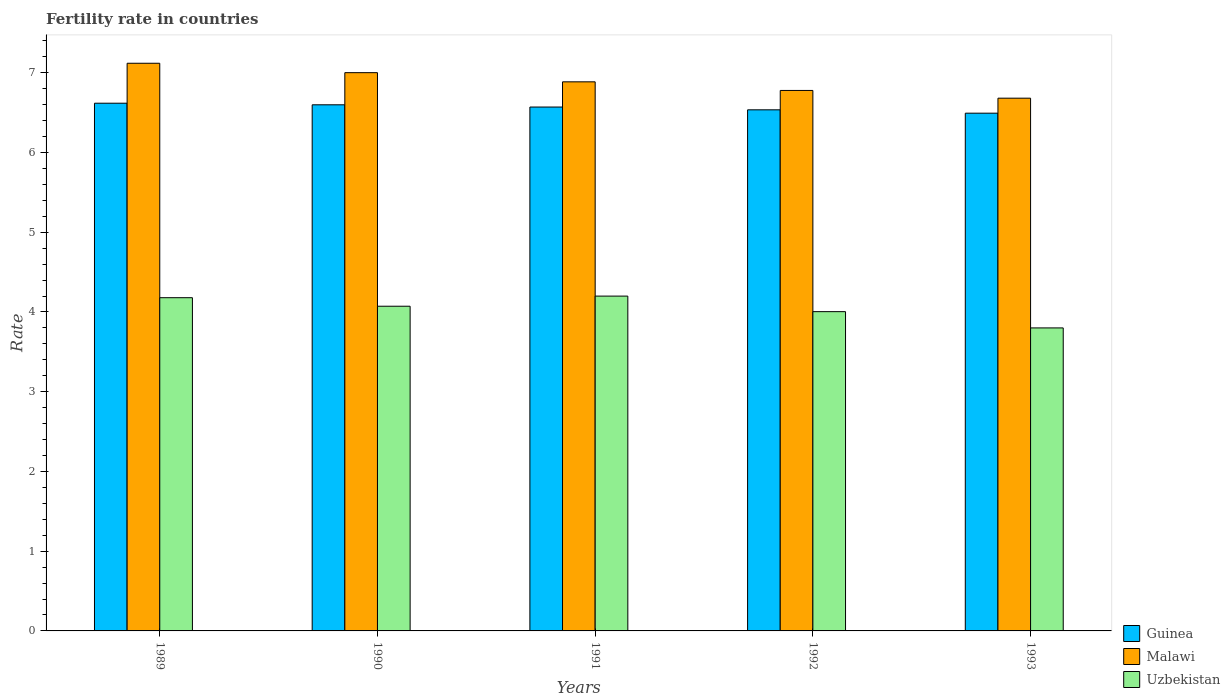How many different coloured bars are there?
Your answer should be very brief. 3. Are the number of bars per tick equal to the number of legend labels?
Offer a terse response. Yes. How many bars are there on the 4th tick from the left?
Offer a terse response. 3. How many bars are there on the 2nd tick from the right?
Provide a succinct answer. 3. In how many cases, is the number of bars for a given year not equal to the number of legend labels?
Give a very brief answer. 0. What is the fertility rate in Uzbekistan in 1990?
Give a very brief answer. 4.07. Across all years, what is the maximum fertility rate in Uzbekistan?
Make the answer very short. 4.2. Across all years, what is the minimum fertility rate in Uzbekistan?
Offer a terse response. 3.8. In which year was the fertility rate in Malawi minimum?
Offer a very short reply. 1993. What is the total fertility rate in Guinea in the graph?
Offer a terse response. 32.81. What is the difference between the fertility rate in Guinea in 1989 and that in 1993?
Make the answer very short. 0.12. What is the difference between the fertility rate in Guinea in 1991 and the fertility rate in Uzbekistan in 1990?
Make the answer very short. 2.5. What is the average fertility rate in Malawi per year?
Give a very brief answer. 6.89. In the year 1989, what is the difference between the fertility rate in Malawi and fertility rate in Guinea?
Give a very brief answer. 0.5. What is the ratio of the fertility rate in Guinea in 1990 to that in 1993?
Offer a terse response. 1.02. Is the difference between the fertility rate in Malawi in 1989 and 1992 greater than the difference between the fertility rate in Guinea in 1989 and 1992?
Provide a short and direct response. Yes. What is the difference between the highest and the second highest fertility rate in Uzbekistan?
Keep it short and to the point. 0.02. What is the difference between the highest and the lowest fertility rate in Uzbekistan?
Make the answer very short. 0.4. What does the 1st bar from the left in 1993 represents?
Provide a succinct answer. Guinea. What does the 2nd bar from the right in 1991 represents?
Offer a very short reply. Malawi. Is it the case that in every year, the sum of the fertility rate in Uzbekistan and fertility rate in Malawi is greater than the fertility rate in Guinea?
Your answer should be very brief. Yes. How many bars are there?
Provide a succinct answer. 15. Are all the bars in the graph horizontal?
Ensure brevity in your answer.  No. Does the graph contain any zero values?
Your answer should be very brief. No. Where does the legend appear in the graph?
Ensure brevity in your answer.  Bottom right. How many legend labels are there?
Give a very brief answer. 3. How are the legend labels stacked?
Offer a very short reply. Vertical. What is the title of the graph?
Offer a very short reply. Fertility rate in countries. What is the label or title of the Y-axis?
Your answer should be compact. Rate. What is the Rate of Guinea in 1989?
Your response must be concise. 6.62. What is the Rate of Malawi in 1989?
Make the answer very short. 7.12. What is the Rate in Uzbekistan in 1989?
Your answer should be very brief. 4.18. What is the Rate of Guinea in 1990?
Ensure brevity in your answer.  6.6. What is the Rate of Malawi in 1990?
Your response must be concise. 7. What is the Rate in Uzbekistan in 1990?
Ensure brevity in your answer.  4.07. What is the Rate in Guinea in 1991?
Give a very brief answer. 6.57. What is the Rate of Malawi in 1991?
Make the answer very short. 6.89. What is the Rate in Uzbekistan in 1991?
Your answer should be very brief. 4.2. What is the Rate of Guinea in 1992?
Your answer should be compact. 6.54. What is the Rate in Malawi in 1992?
Ensure brevity in your answer.  6.78. What is the Rate of Uzbekistan in 1992?
Give a very brief answer. 4. What is the Rate of Guinea in 1993?
Offer a very short reply. 6.49. What is the Rate in Malawi in 1993?
Your answer should be very brief. 6.68. What is the Rate in Uzbekistan in 1993?
Ensure brevity in your answer.  3.8. Across all years, what is the maximum Rate of Guinea?
Offer a terse response. 6.62. Across all years, what is the maximum Rate of Malawi?
Provide a succinct answer. 7.12. Across all years, what is the maximum Rate of Uzbekistan?
Ensure brevity in your answer.  4.2. Across all years, what is the minimum Rate of Guinea?
Provide a succinct answer. 6.49. Across all years, what is the minimum Rate in Malawi?
Your answer should be very brief. 6.68. Across all years, what is the minimum Rate of Uzbekistan?
Your answer should be compact. 3.8. What is the total Rate of Guinea in the graph?
Give a very brief answer. 32.81. What is the total Rate of Malawi in the graph?
Offer a terse response. 34.47. What is the total Rate in Uzbekistan in the graph?
Make the answer very short. 20.25. What is the difference between the Rate in Malawi in 1989 and that in 1990?
Give a very brief answer. 0.12. What is the difference between the Rate of Uzbekistan in 1989 and that in 1990?
Keep it short and to the point. 0.11. What is the difference between the Rate of Guinea in 1989 and that in 1991?
Provide a succinct answer. 0.05. What is the difference between the Rate of Malawi in 1989 and that in 1991?
Provide a succinct answer. 0.23. What is the difference between the Rate of Uzbekistan in 1989 and that in 1991?
Make the answer very short. -0.02. What is the difference between the Rate of Guinea in 1989 and that in 1992?
Your response must be concise. 0.08. What is the difference between the Rate in Malawi in 1989 and that in 1992?
Make the answer very short. 0.34. What is the difference between the Rate in Uzbekistan in 1989 and that in 1992?
Your response must be concise. 0.17. What is the difference between the Rate of Malawi in 1989 and that in 1993?
Provide a succinct answer. 0.44. What is the difference between the Rate in Uzbekistan in 1989 and that in 1993?
Offer a very short reply. 0.38. What is the difference between the Rate in Guinea in 1990 and that in 1991?
Ensure brevity in your answer.  0.03. What is the difference between the Rate in Malawi in 1990 and that in 1991?
Your response must be concise. 0.12. What is the difference between the Rate in Uzbekistan in 1990 and that in 1991?
Your answer should be very brief. -0.13. What is the difference between the Rate in Guinea in 1990 and that in 1992?
Ensure brevity in your answer.  0.06. What is the difference between the Rate of Malawi in 1990 and that in 1992?
Provide a succinct answer. 0.22. What is the difference between the Rate of Uzbekistan in 1990 and that in 1992?
Offer a terse response. 0.07. What is the difference between the Rate in Guinea in 1990 and that in 1993?
Make the answer very short. 0.1. What is the difference between the Rate in Malawi in 1990 and that in 1993?
Give a very brief answer. 0.32. What is the difference between the Rate of Uzbekistan in 1990 and that in 1993?
Make the answer very short. 0.27. What is the difference between the Rate of Guinea in 1991 and that in 1992?
Provide a succinct answer. 0.04. What is the difference between the Rate of Malawi in 1991 and that in 1992?
Keep it short and to the point. 0.11. What is the difference between the Rate in Uzbekistan in 1991 and that in 1992?
Keep it short and to the point. 0.2. What is the difference between the Rate of Guinea in 1991 and that in 1993?
Your answer should be very brief. 0.08. What is the difference between the Rate in Malawi in 1991 and that in 1993?
Give a very brief answer. 0.2. What is the difference between the Rate in Uzbekistan in 1991 and that in 1993?
Your answer should be very brief. 0.4. What is the difference between the Rate of Guinea in 1992 and that in 1993?
Your response must be concise. 0.04. What is the difference between the Rate of Malawi in 1992 and that in 1993?
Your answer should be compact. 0.1. What is the difference between the Rate of Uzbekistan in 1992 and that in 1993?
Your response must be concise. 0.2. What is the difference between the Rate in Guinea in 1989 and the Rate in Malawi in 1990?
Offer a very short reply. -0.38. What is the difference between the Rate in Guinea in 1989 and the Rate in Uzbekistan in 1990?
Give a very brief answer. 2.55. What is the difference between the Rate of Malawi in 1989 and the Rate of Uzbekistan in 1990?
Ensure brevity in your answer.  3.05. What is the difference between the Rate in Guinea in 1989 and the Rate in Malawi in 1991?
Keep it short and to the point. -0.27. What is the difference between the Rate in Guinea in 1989 and the Rate in Uzbekistan in 1991?
Keep it short and to the point. 2.42. What is the difference between the Rate in Malawi in 1989 and the Rate in Uzbekistan in 1991?
Give a very brief answer. 2.92. What is the difference between the Rate in Guinea in 1989 and the Rate in Malawi in 1992?
Offer a very short reply. -0.16. What is the difference between the Rate of Guinea in 1989 and the Rate of Uzbekistan in 1992?
Make the answer very short. 2.61. What is the difference between the Rate of Malawi in 1989 and the Rate of Uzbekistan in 1992?
Keep it short and to the point. 3.12. What is the difference between the Rate in Guinea in 1989 and the Rate in Malawi in 1993?
Your answer should be very brief. -0.06. What is the difference between the Rate of Guinea in 1989 and the Rate of Uzbekistan in 1993?
Keep it short and to the point. 2.82. What is the difference between the Rate of Malawi in 1989 and the Rate of Uzbekistan in 1993?
Keep it short and to the point. 3.32. What is the difference between the Rate in Guinea in 1990 and the Rate in Malawi in 1991?
Your answer should be compact. -0.29. What is the difference between the Rate of Guinea in 1990 and the Rate of Uzbekistan in 1991?
Offer a very short reply. 2.4. What is the difference between the Rate in Malawi in 1990 and the Rate in Uzbekistan in 1991?
Provide a succinct answer. 2.8. What is the difference between the Rate in Guinea in 1990 and the Rate in Malawi in 1992?
Provide a succinct answer. -0.18. What is the difference between the Rate in Guinea in 1990 and the Rate in Uzbekistan in 1992?
Provide a succinct answer. 2.59. What is the difference between the Rate of Malawi in 1990 and the Rate of Uzbekistan in 1992?
Your response must be concise. 3. What is the difference between the Rate of Guinea in 1990 and the Rate of Malawi in 1993?
Provide a short and direct response. -0.08. What is the difference between the Rate of Guinea in 1990 and the Rate of Uzbekistan in 1993?
Give a very brief answer. 2.8. What is the difference between the Rate in Malawi in 1990 and the Rate in Uzbekistan in 1993?
Offer a terse response. 3.2. What is the difference between the Rate in Guinea in 1991 and the Rate in Malawi in 1992?
Provide a short and direct response. -0.21. What is the difference between the Rate in Guinea in 1991 and the Rate in Uzbekistan in 1992?
Give a very brief answer. 2.57. What is the difference between the Rate in Malawi in 1991 and the Rate in Uzbekistan in 1992?
Your response must be concise. 2.88. What is the difference between the Rate of Guinea in 1991 and the Rate of Malawi in 1993?
Provide a short and direct response. -0.11. What is the difference between the Rate in Guinea in 1991 and the Rate in Uzbekistan in 1993?
Offer a very short reply. 2.77. What is the difference between the Rate in Malawi in 1991 and the Rate in Uzbekistan in 1993?
Ensure brevity in your answer.  3.09. What is the difference between the Rate in Guinea in 1992 and the Rate in Malawi in 1993?
Give a very brief answer. -0.15. What is the difference between the Rate of Guinea in 1992 and the Rate of Uzbekistan in 1993?
Offer a terse response. 2.73. What is the difference between the Rate of Malawi in 1992 and the Rate of Uzbekistan in 1993?
Provide a short and direct response. 2.98. What is the average Rate of Guinea per year?
Offer a terse response. 6.56. What is the average Rate of Malawi per year?
Provide a succinct answer. 6.89. What is the average Rate of Uzbekistan per year?
Give a very brief answer. 4.05. In the year 1989, what is the difference between the Rate in Guinea and Rate in Malawi?
Your answer should be compact. -0.5. In the year 1989, what is the difference between the Rate in Guinea and Rate in Uzbekistan?
Your answer should be compact. 2.44. In the year 1989, what is the difference between the Rate in Malawi and Rate in Uzbekistan?
Your answer should be compact. 2.94. In the year 1990, what is the difference between the Rate of Guinea and Rate of Malawi?
Ensure brevity in your answer.  -0.4. In the year 1990, what is the difference between the Rate of Guinea and Rate of Uzbekistan?
Ensure brevity in your answer.  2.53. In the year 1990, what is the difference between the Rate of Malawi and Rate of Uzbekistan?
Provide a succinct answer. 2.93. In the year 1991, what is the difference between the Rate in Guinea and Rate in Malawi?
Make the answer very short. -0.32. In the year 1991, what is the difference between the Rate of Guinea and Rate of Uzbekistan?
Offer a very short reply. 2.37. In the year 1991, what is the difference between the Rate of Malawi and Rate of Uzbekistan?
Give a very brief answer. 2.69. In the year 1992, what is the difference between the Rate of Guinea and Rate of Malawi?
Provide a short and direct response. -0.24. In the year 1992, what is the difference between the Rate in Guinea and Rate in Uzbekistan?
Offer a terse response. 2.53. In the year 1992, what is the difference between the Rate of Malawi and Rate of Uzbekistan?
Your answer should be very brief. 2.77. In the year 1993, what is the difference between the Rate in Guinea and Rate in Malawi?
Ensure brevity in your answer.  -0.19. In the year 1993, what is the difference between the Rate of Guinea and Rate of Uzbekistan?
Your answer should be very brief. 2.69. In the year 1993, what is the difference between the Rate of Malawi and Rate of Uzbekistan?
Offer a very short reply. 2.88. What is the ratio of the Rate of Malawi in 1989 to that in 1990?
Ensure brevity in your answer.  1.02. What is the ratio of the Rate in Uzbekistan in 1989 to that in 1990?
Ensure brevity in your answer.  1.03. What is the ratio of the Rate of Guinea in 1989 to that in 1991?
Provide a succinct answer. 1.01. What is the ratio of the Rate of Malawi in 1989 to that in 1991?
Keep it short and to the point. 1.03. What is the ratio of the Rate of Guinea in 1989 to that in 1992?
Your answer should be very brief. 1.01. What is the ratio of the Rate in Malawi in 1989 to that in 1992?
Your response must be concise. 1.05. What is the ratio of the Rate of Uzbekistan in 1989 to that in 1992?
Give a very brief answer. 1.04. What is the ratio of the Rate in Guinea in 1989 to that in 1993?
Make the answer very short. 1.02. What is the ratio of the Rate in Malawi in 1989 to that in 1993?
Offer a very short reply. 1.07. What is the ratio of the Rate in Uzbekistan in 1989 to that in 1993?
Your answer should be very brief. 1.1. What is the ratio of the Rate of Guinea in 1990 to that in 1991?
Provide a succinct answer. 1. What is the ratio of the Rate in Malawi in 1990 to that in 1991?
Offer a very short reply. 1.02. What is the ratio of the Rate in Uzbekistan in 1990 to that in 1991?
Ensure brevity in your answer.  0.97. What is the ratio of the Rate in Guinea in 1990 to that in 1992?
Ensure brevity in your answer.  1.01. What is the ratio of the Rate in Malawi in 1990 to that in 1992?
Your answer should be very brief. 1.03. What is the ratio of the Rate in Guinea in 1990 to that in 1993?
Give a very brief answer. 1.02. What is the ratio of the Rate of Malawi in 1990 to that in 1993?
Offer a terse response. 1.05. What is the ratio of the Rate of Uzbekistan in 1990 to that in 1993?
Give a very brief answer. 1.07. What is the ratio of the Rate in Guinea in 1991 to that in 1992?
Offer a terse response. 1.01. What is the ratio of the Rate of Malawi in 1991 to that in 1992?
Provide a succinct answer. 1.02. What is the ratio of the Rate in Uzbekistan in 1991 to that in 1992?
Your answer should be very brief. 1.05. What is the ratio of the Rate of Guinea in 1991 to that in 1993?
Ensure brevity in your answer.  1.01. What is the ratio of the Rate in Malawi in 1991 to that in 1993?
Your response must be concise. 1.03. What is the ratio of the Rate in Uzbekistan in 1991 to that in 1993?
Keep it short and to the point. 1.1. What is the ratio of the Rate in Malawi in 1992 to that in 1993?
Your answer should be compact. 1.01. What is the ratio of the Rate in Uzbekistan in 1992 to that in 1993?
Provide a short and direct response. 1.05. What is the difference between the highest and the second highest Rate in Malawi?
Your response must be concise. 0.12. What is the difference between the highest and the lowest Rate in Malawi?
Your answer should be very brief. 0.44. What is the difference between the highest and the lowest Rate in Uzbekistan?
Offer a very short reply. 0.4. 